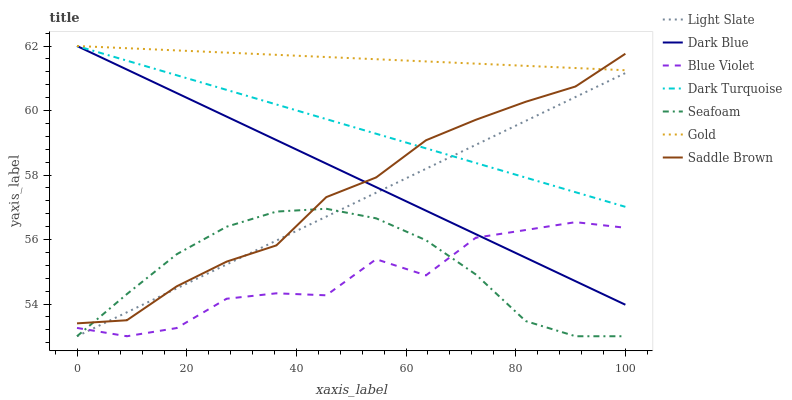Does Blue Violet have the minimum area under the curve?
Answer yes or no. Yes. Does Gold have the maximum area under the curve?
Answer yes or no. Yes. Does Light Slate have the minimum area under the curve?
Answer yes or no. No. Does Light Slate have the maximum area under the curve?
Answer yes or no. No. Is Dark Blue the smoothest?
Answer yes or no. Yes. Is Blue Violet the roughest?
Answer yes or no. Yes. Is Light Slate the smoothest?
Answer yes or no. No. Is Light Slate the roughest?
Answer yes or no. No. Does Light Slate have the lowest value?
Answer yes or no. Yes. Does Dark Turquoise have the lowest value?
Answer yes or no. No. Does Dark Blue have the highest value?
Answer yes or no. Yes. Does Light Slate have the highest value?
Answer yes or no. No. Is Light Slate less than Gold?
Answer yes or no. Yes. Is Dark Turquoise greater than Seafoam?
Answer yes or no. Yes. Does Blue Violet intersect Dark Blue?
Answer yes or no. Yes. Is Blue Violet less than Dark Blue?
Answer yes or no. No. Is Blue Violet greater than Dark Blue?
Answer yes or no. No. Does Light Slate intersect Gold?
Answer yes or no. No. 